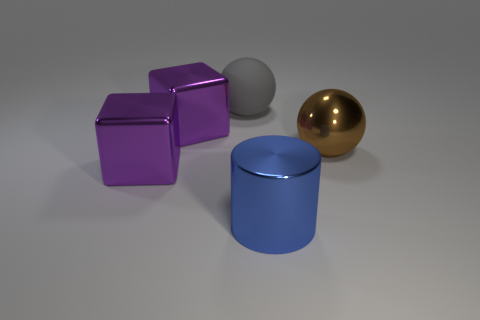Considering the arrangement of objects, what basic principles of design does this image illustrate? This image demonstrates several foundational principles of design, including contrast, as shown by the different textures (shiny vs. matte) and the colors (purple, blue, and gold). Balance is evident through the symmetrical placement of the cubes and spheres, each positioned on opposite sides of the central cylinder. There's also an emphasis on simple geometric forms, with the cubes, sphere, and cylinder, that captures the essence of minimalist design. 